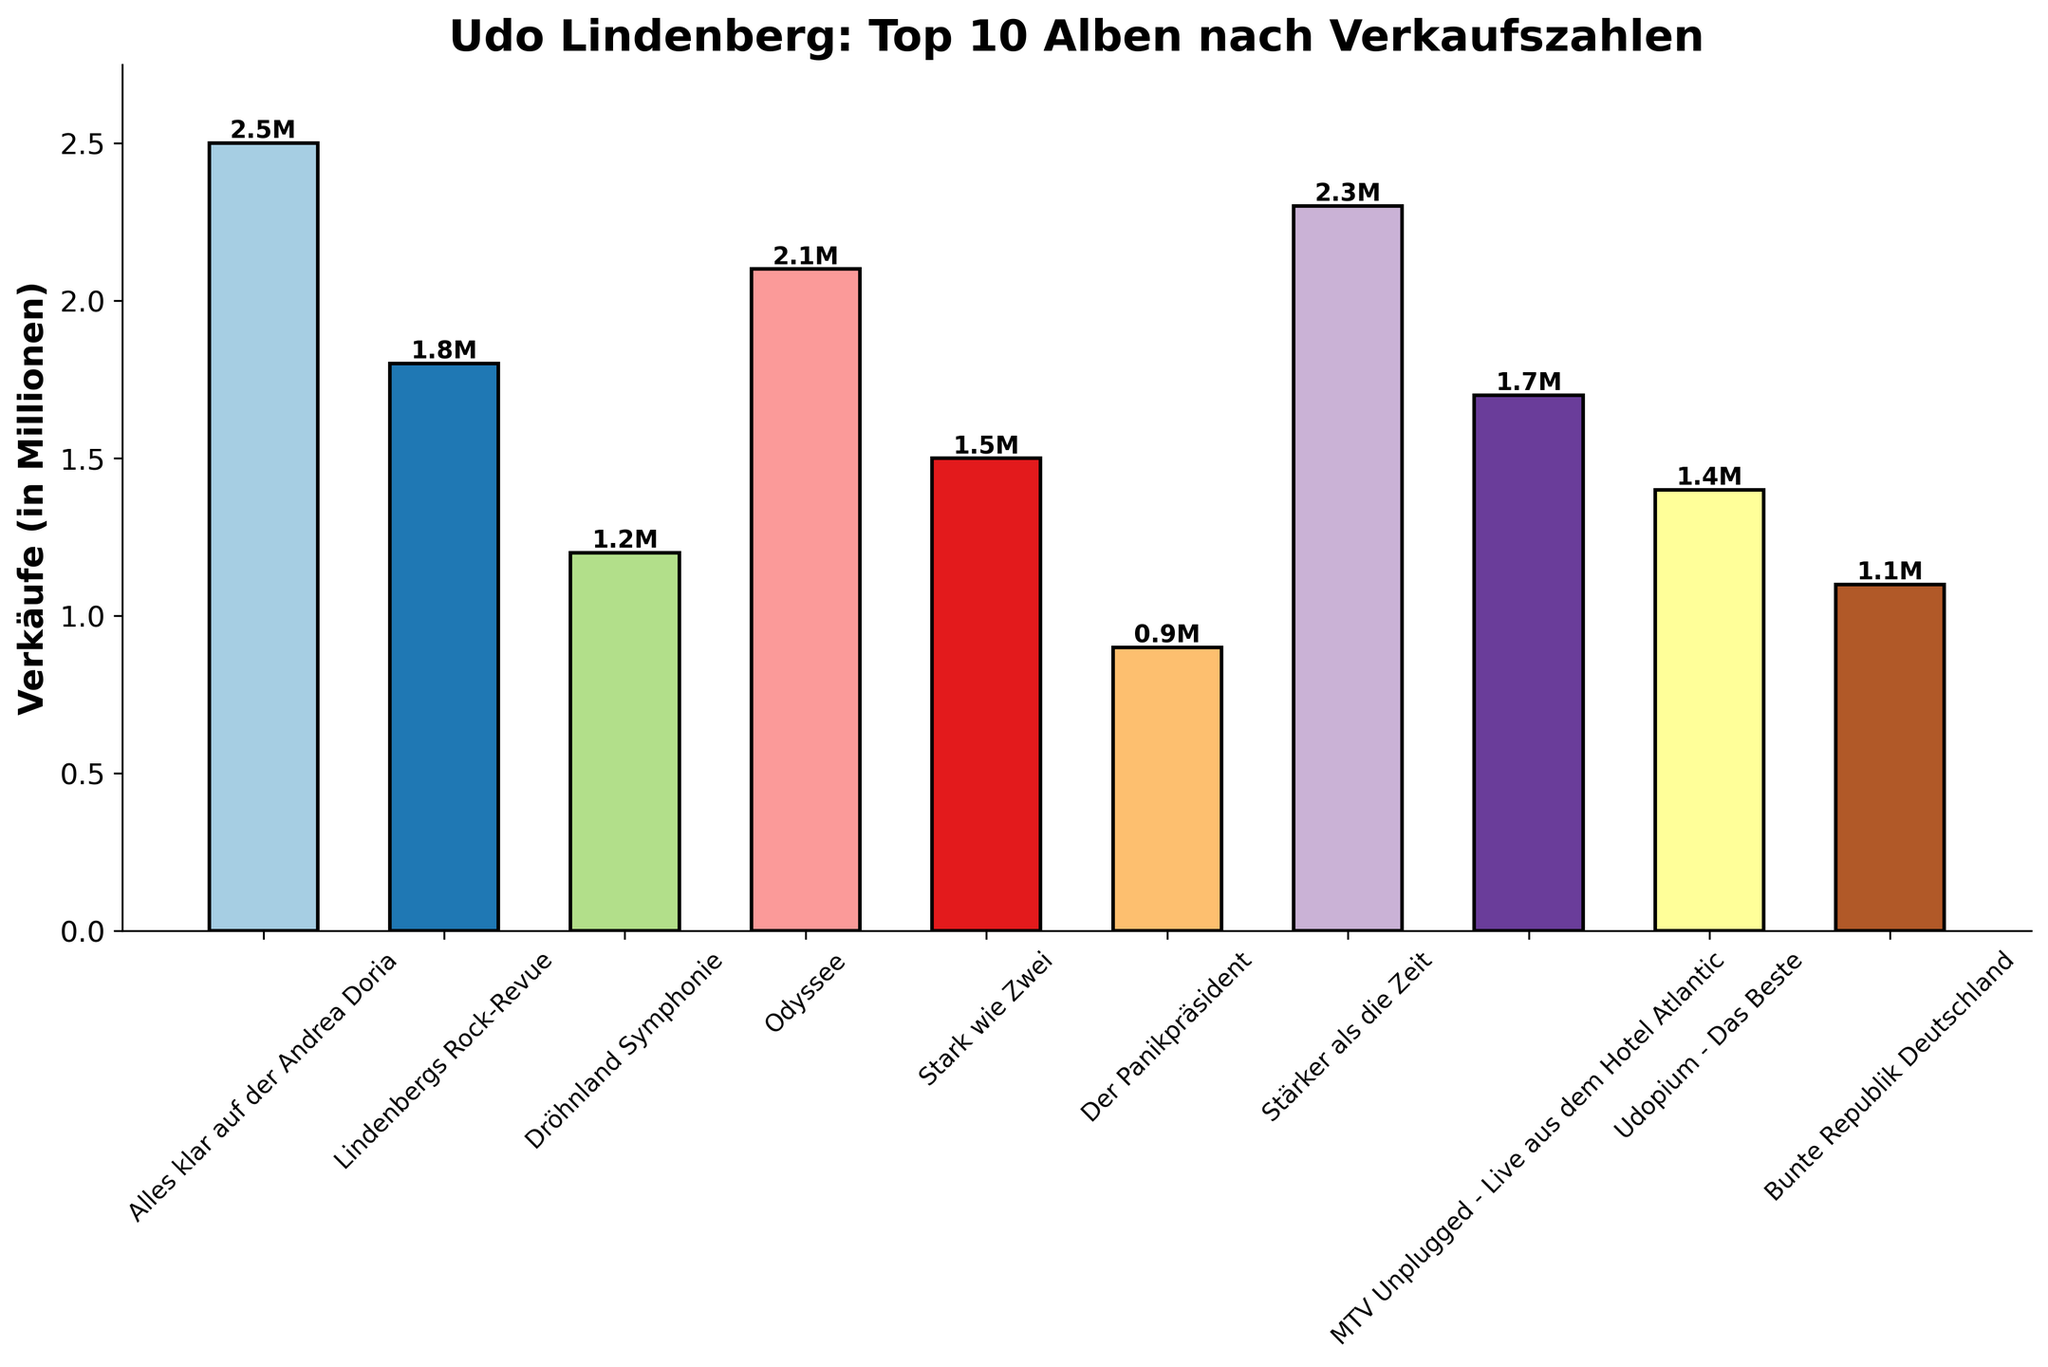Which album has the highest sales? The album 'Alles klar auf der Andrea Doria' has a bar reaching the highest point on the sales axis, indicating the highest sales.
Answer: Alles klar auf der Andrea Doria Which album has the lowest sales? The album 'Der Panikpräsident' has the shortest bar, indicating the lowest sales.
Answer: Der Panikpräsident What is the difference in sales between 'Stärker als die Zeit' and 'Bunte Republik Deutschland'? 'Stärker als die Zeit' has sales of 2.3 million, and 'Bunte Republik Deutschland' has sales of 1.1 million. The difference is 2.3 - 1.1 = 1.2 million.
Answer: 1.2 million Which album came second in terms of sales? The album 'Odyssee' has the second highest bar after 'Alles klar auf der Andrea Doria,' indicating it has the second highest sales.
Answer: Odyssee What are the total sales of 'Lindenbergs Rock-Revue' and 'Stark wie Zwei'? 'Lindenbergs Rock-Revue' has sales of 1.8 million and 'Stark wie Zwei' has sales of 1.5 million. The total is 1.8 + 1.5 = 3.3 million.
Answer: 3.3 million Which albums have sales greater than 2 million? The albums 'Alles klar auf der Andrea Doria,' 'Odyssee,' and 'Stärker als die Zeit' all have bars extending beyond the 2 million mark on the sales axis.
Answer: Alles klar auf der Andrea Doria, Odyssee, Stärker als die Zeit How many albums have sales between 1 million and 2 million? By examining the bars, the albums 'Lindenbergs Rock-Revue,' 'MTV Unplugged - Live aus dem Hotel Atlantic,' 'Udopium - Das Beste,' and 'Bunte Republik Deutschland' fall within the sales range of 1 to 2 million.
Answer: Four What are the combined sales of the top 3 albums? The top 3 albums are 'Alles klar auf der Andrea Doria' (2.5 million), 'Odyssee' (2.1 million), and 'Stärker als die Zeit' (2.3 million). The combined sales are 2.5 + 2.1 + 2.3 = 6.9 million.
Answer: 6.9 million Which album has slightly better sales than 'Udopium - Das Beste'? The album 'Stark wie Zwei' has sales of 1.5 million, slightly higher than 'Udopium - Das Beste' with 1.4 million.
Answer: Stark wie Zwei What is the average sales of all the albums? Adding the sales of all albums: 2.5 + 1.8 + 1.2 + 2.1 + 1.5 + 0.9 + 2.3 + 1.7 + 1.4 + 1.1 = 16.5 million. Dividing by the number of albums (10) gives the average: 16.5 / 10 = 1.65 million.
Answer: 1.65 million 